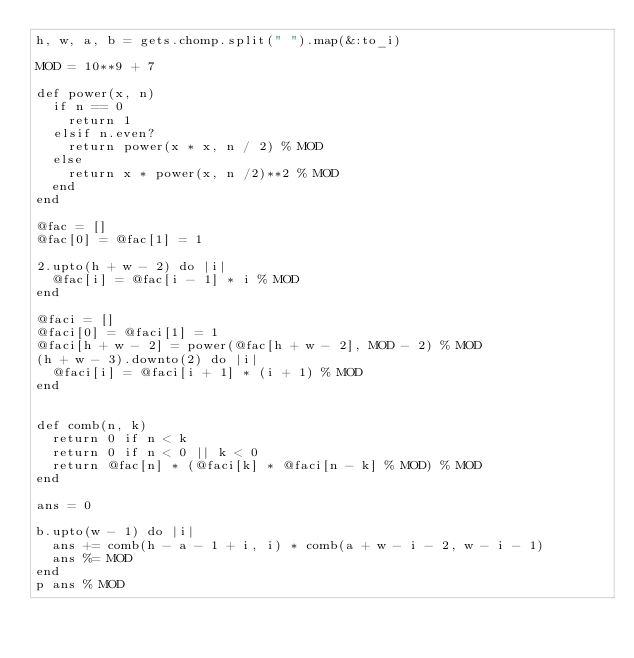Convert code to text. <code><loc_0><loc_0><loc_500><loc_500><_Ruby_>h, w, a, b = gets.chomp.split(" ").map(&:to_i)

MOD = 10**9 + 7

def power(x, n)
  if n == 0
    return 1
  elsif n.even?
    return power(x * x, n / 2) % MOD
  else
    return x * power(x, n /2)**2 % MOD
  end
end

@fac = []
@fac[0] = @fac[1] = 1

2.upto(h + w - 2) do |i|
  @fac[i] = @fac[i - 1] * i % MOD
end

@faci = []
@faci[0] = @faci[1] = 1
@faci[h + w - 2] = power(@fac[h + w - 2], MOD - 2) % MOD
(h + w - 3).downto(2) do |i|
  @faci[i] = @faci[i + 1] * (i + 1) % MOD
end


def comb(n, k)
  return 0 if n < k
  return 0 if n < 0 || k < 0
  return @fac[n] * (@faci[k] * @faci[n - k] % MOD) % MOD
end

ans = 0

b.upto(w - 1) do |i|
  ans += comb(h - a - 1 + i, i) * comb(a + w - i - 2, w - i - 1)
  ans %= MOD
end
p ans % MOD

</code> 